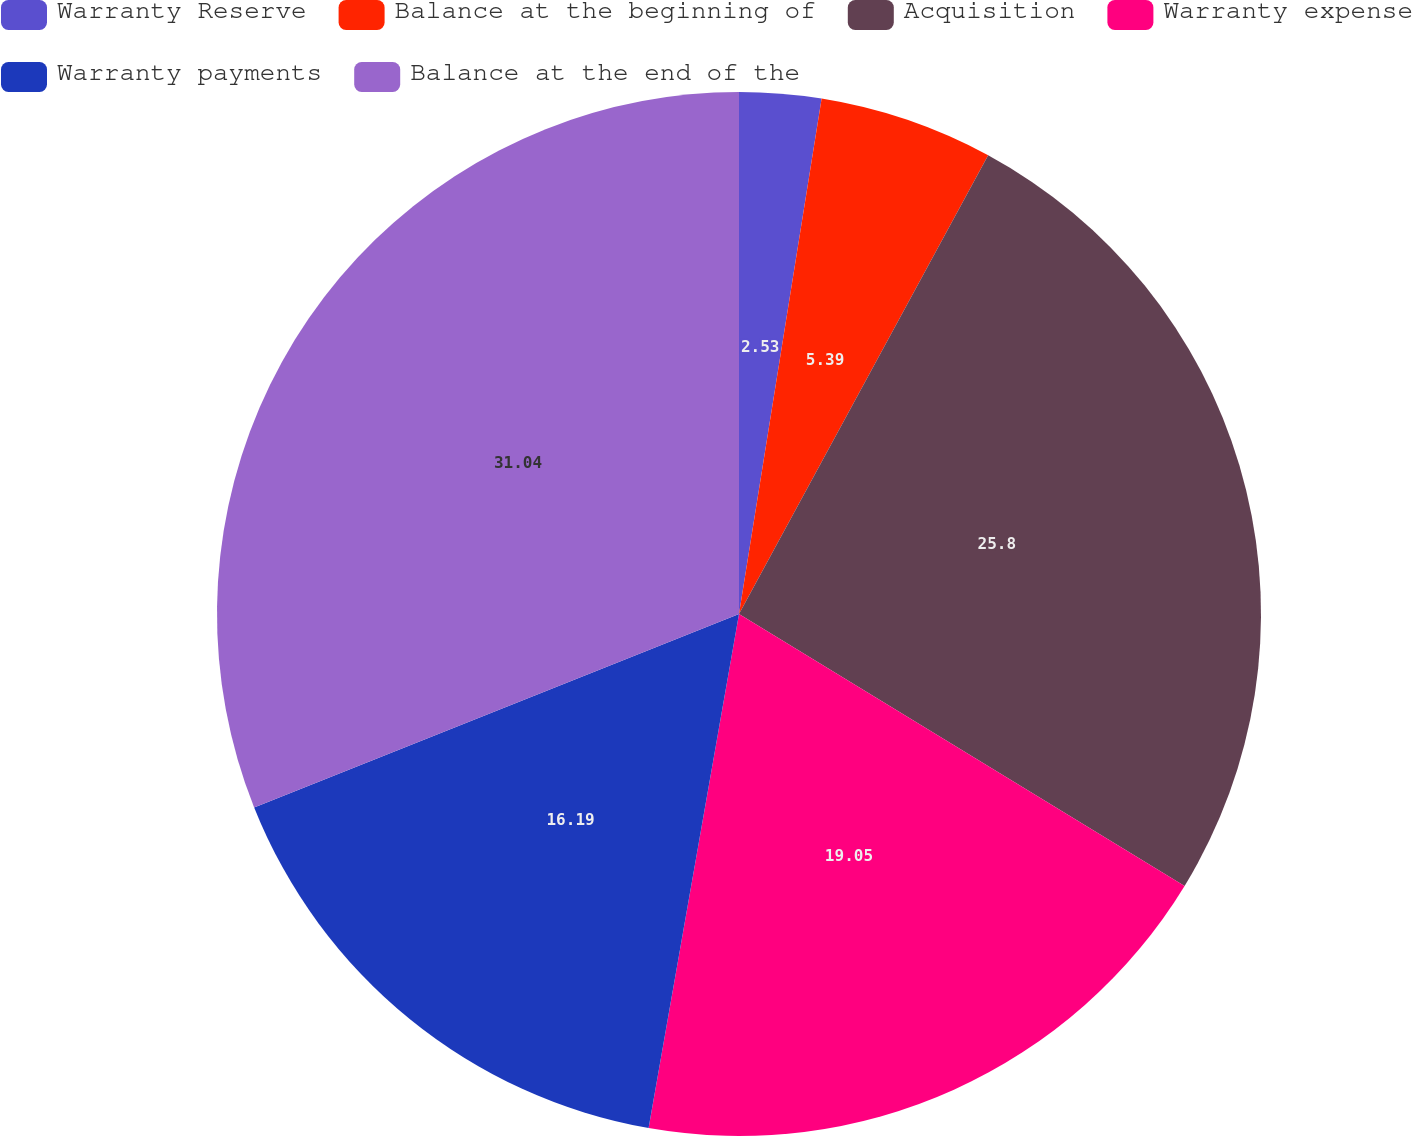Convert chart. <chart><loc_0><loc_0><loc_500><loc_500><pie_chart><fcel>Warranty Reserve<fcel>Balance at the beginning of<fcel>Acquisition<fcel>Warranty expense<fcel>Warranty payments<fcel>Balance at the end of the<nl><fcel>2.53%<fcel>5.39%<fcel>25.8%<fcel>19.05%<fcel>16.19%<fcel>31.04%<nl></chart> 